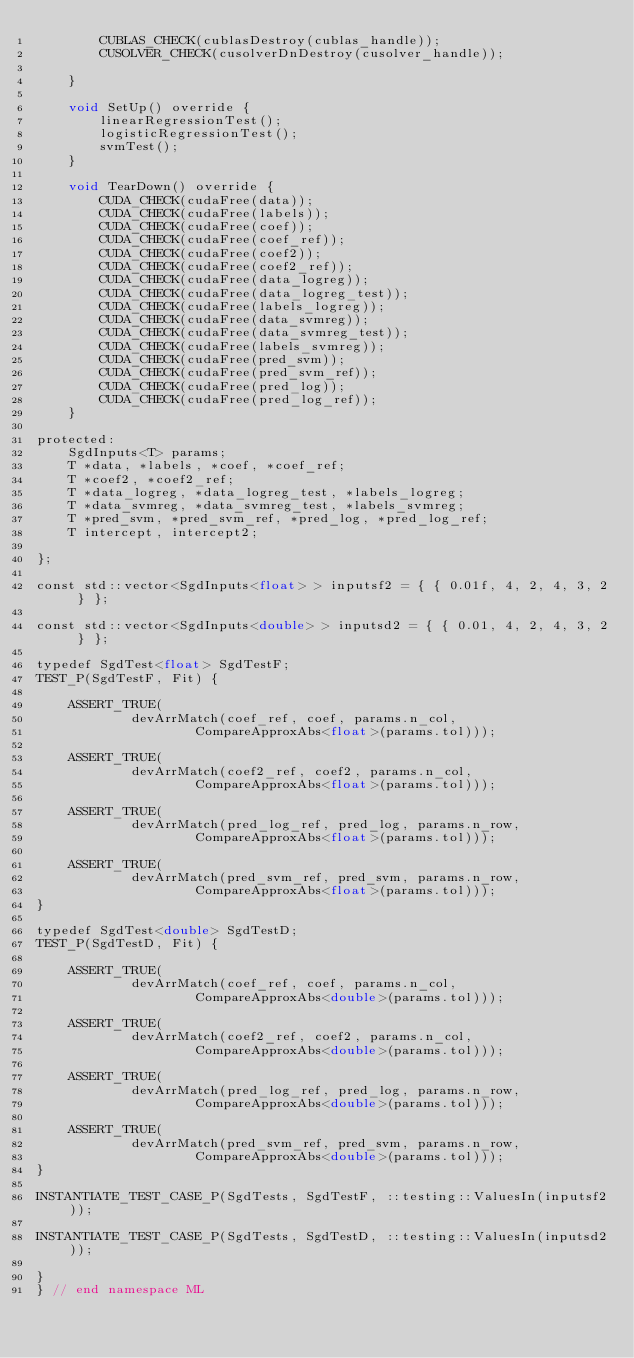<code> <loc_0><loc_0><loc_500><loc_500><_Cuda_>		CUBLAS_CHECK(cublasDestroy(cublas_handle));
		CUSOLVER_CHECK(cusolverDnDestroy(cusolver_handle));

	}

	void SetUp() override {
		linearRegressionTest();
		logisticRegressionTest();
		svmTest();
	}

	void TearDown() override {
		CUDA_CHECK(cudaFree(data));
		CUDA_CHECK(cudaFree(labels));
		CUDA_CHECK(cudaFree(coef));
		CUDA_CHECK(cudaFree(coef_ref));
		CUDA_CHECK(cudaFree(coef2));
		CUDA_CHECK(cudaFree(coef2_ref));
		CUDA_CHECK(cudaFree(data_logreg));
		CUDA_CHECK(cudaFree(data_logreg_test));
		CUDA_CHECK(cudaFree(labels_logreg));
		CUDA_CHECK(cudaFree(data_svmreg));
		CUDA_CHECK(cudaFree(data_svmreg_test));
		CUDA_CHECK(cudaFree(labels_svmreg));
		CUDA_CHECK(cudaFree(pred_svm));
		CUDA_CHECK(cudaFree(pred_svm_ref));
		CUDA_CHECK(cudaFree(pred_log));
		CUDA_CHECK(cudaFree(pred_log_ref));
	}

protected:
	SgdInputs<T> params;
	T *data, *labels, *coef, *coef_ref;
	T *coef2, *coef2_ref;
	T *data_logreg, *data_logreg_test, *labels_logreg;
	T *data_svmreg, *data_svmreg_test, *labels_svmreg;
	T *pred_svm, *pred_svm_ref, *pred_log, *pred_log_ref;
	T intercept, intercept2;

};

const std::vector<SgdInputs<float> > inputsf2 = { { 0.01f, 4, 2, 4, 3, 2 } };

const std::vector<SgdInputs<double> > inputsd2 = { { 0.01, 4, 2, 4, 3, 2 } };

typedef SgdTest<float> SgdTestF;
TEST_P(SgdTestF, Fit) {

	ASSERT_TRUE(
			devArrMatch(coef_ref, coef, params.n_col,
					CompareApproxAbs<float>(params.tol)));

	ASSERT_TRUE(
			devArrMatch(coef2_ref, coef2, params.n_col,
					CompareApproxAbs<float>(params.tol)));

	ASSERT_TRUE(
			devArrMatch(pred_log_ref, pred_log, params.n_row,
					CompareApproxAbs<float>(params.tol)));

	ASSERT_TRUE(
			devArrMatch(pred_svm_ref, pred_svm, params.n_row,
					CompareApproxAbs<float>(params.tol)));
}

typedef SgdTest<double> SgdTestD;
TEST_P(SgdTestD, Fit) {

	ASSERT_TRUE(
			devArrMatch(coef_ref, coef, params.n_col,
					CompareApproxAbs<double>(params.tol)));

	ASSERT_TRUE(
			devArrMatch(coef2_ref, coef2, params.n_col,
					CompareApproxAbs<double>(params.tol)));

	ASSERT_TRUE(
			devArrMatch(pred_log_ref, pred_log, params.n_row,
					CompareApproxAbs<double>(params.tol)));

	ASSERT_TRUE(
			devArrMatch(pred_svm_ref, pred_svm, params.n_row,
					CompareApproxAbs<double>(params.tol)));
}

INSTANTIATE_TEST_CASE_P(SgdTests, SgdTestF, ::testing::ValuesIn(inputsf2));

INSTANTIATE_TEST_CASE_P(SgdTests, SgdTestD, ::testing::ValuesIn(inputsd2));

}
} // end namespace ML
</code> 